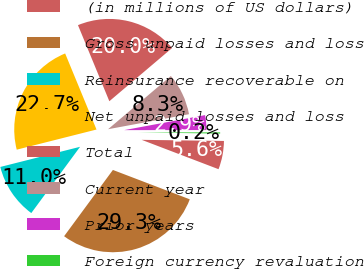<chart> <loc_0><loc_0><loc_500><loc_500><pie_chart><fcel>(in millions of US dollars)<fcel>Gross unpaid losses and loss<fcel>Reinsurance recoverable on<fcel>Net unpaid losses and loss<fcel>Total<fcel>Current year<fcel>Prior years<fcel>Foreign currency revaluation<nl><fcel>5.59%<fcel>29.29%<fcel>10.96%<fcel>22.71%<fcel>20.03%<fcel>8.27%<fcel>2.91%<fcel>0.23%<nl></chart> 